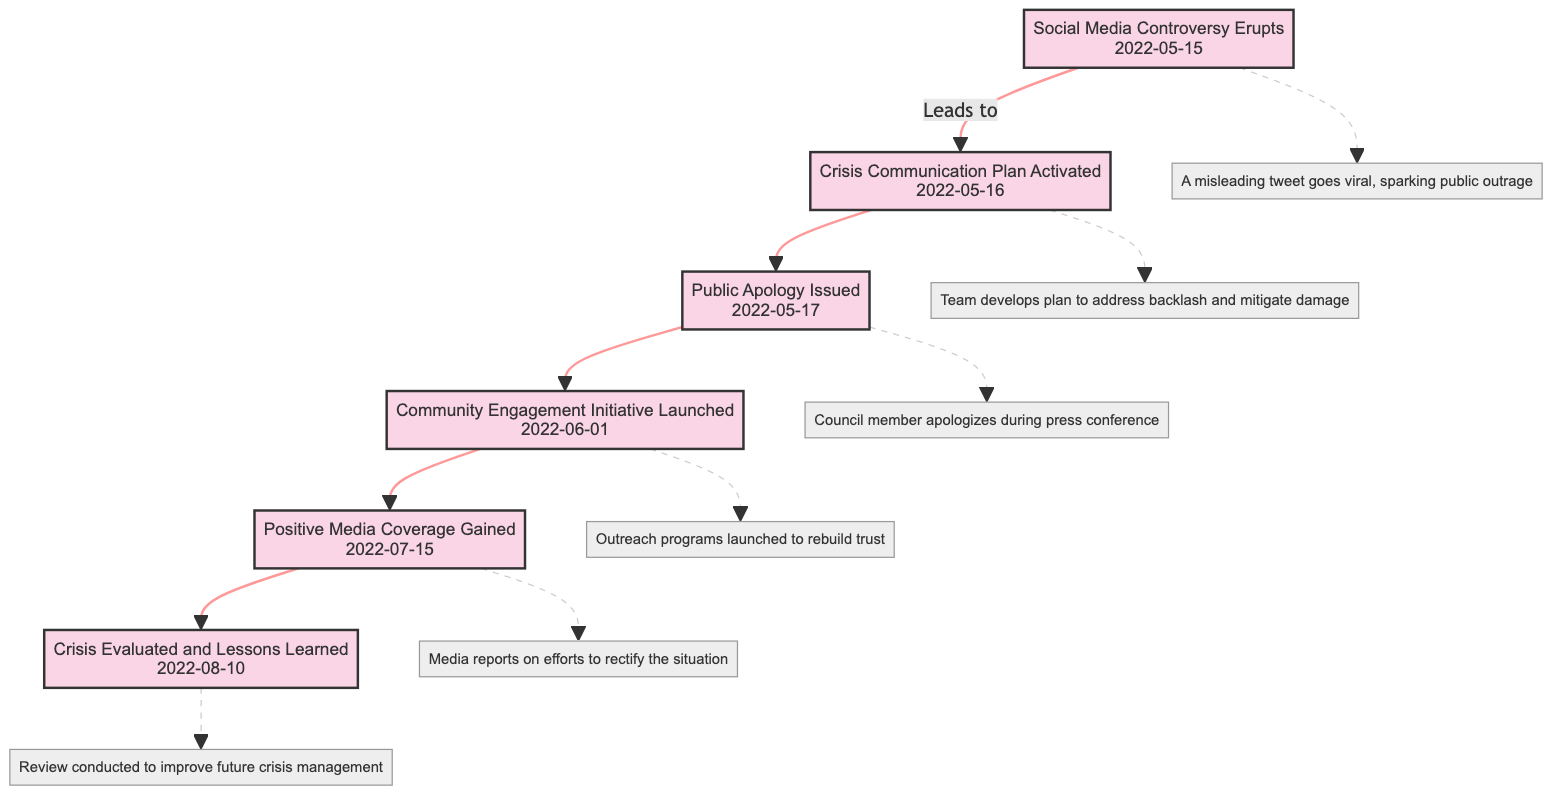What event led to the activation of the crisis communication plan? The diagram indicates that the "Social Media Controversy Erupts" event directly leads to the activation of the "Crisis Communication Plan." This relationship is depicted by an arrow connecting the two nodes.
Answer: Social Media Controversy Erupts What date did the council member issue a public apology? From the diagram, the node labeled "Public Apology Issued" details that this event took place on "2022-05-17." This can be read directly from the node's information.
Answer: 2022-05-17 How many events are listed in the diagram? By counting the distinct event nodes in the diagram, we find there are six events shown in the directed graph. Each event is represented as a node interconnected by arrows, indicating the flow of the crisis management timeline.
Answer: 6 What follows after the "Community Engagement Initiative Launched"? The directed graph shows that the node "Community Engagement Initiative Launched" points to the next event, which is "Positive Media Coverage Gained." This indicates the order of events and the response process taken.
Answer: Positive Media Coverage Gained What is the main focus of the "Crisis Evaluated and Lessons Learned" event? According to the diagram, the description under this event indicates that it involves a review conducted by the communications team to identify improvements for future crisis management. This information is directly connected to the node's description.
Answer: Review conducted to improve future crisis management What type of communication plan was activated after the controversy? The graph specifies that a "Crisis Communication Plan" was activated immediately after the social media controversy erupted, showcasing the immediate response to the crisis encountered.
Answer: Crisis Communication Plan What was the reaction of the media following the council member's corrective actions? The diagram indicates that after the launch of the "Community Engagement Initiative," the media began to report positively on the council member's efforts, which is represented in the "Positive Media Coverage Gained" node.
Answer: Positive media coverage gained 